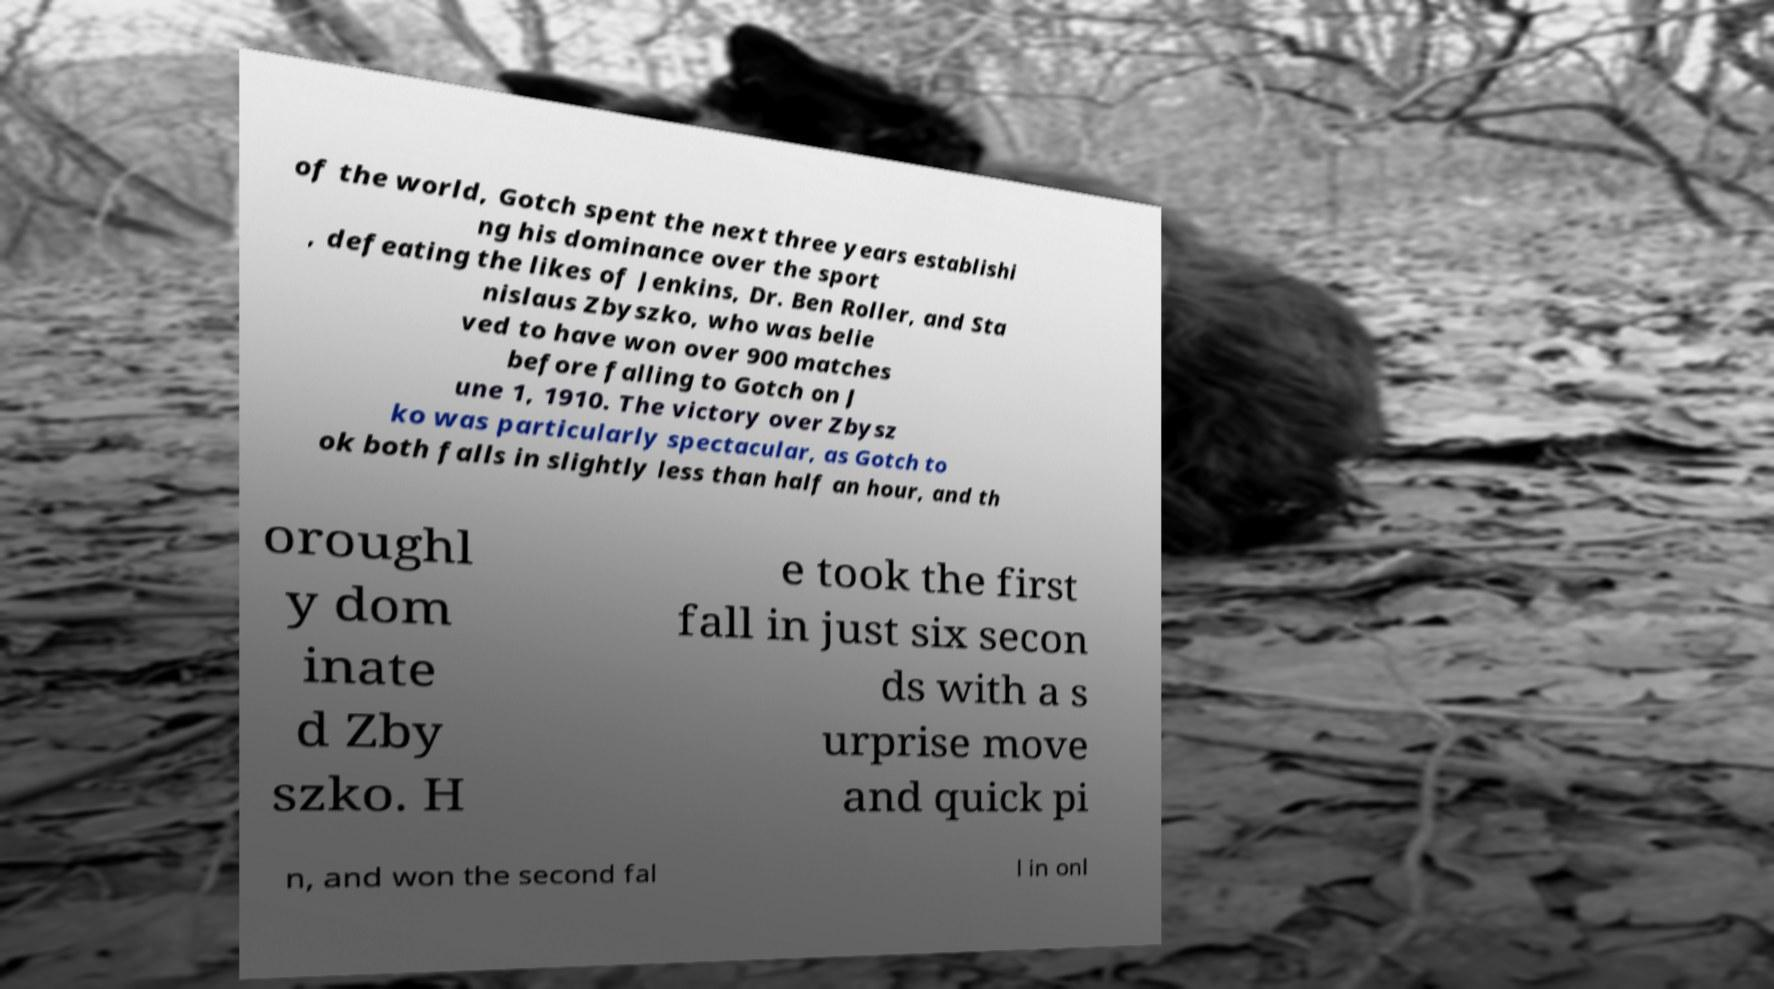I need the written content from this picture converted into text. Can you do that? of the world, Gotch spent the next three years establishi ng his dominance over the sport , defeating the likes of Jenkins, Dr. Ben Roller, and Sta nislaus Zbyszko, who was belie ved to have won over 900 matches before falling to Gotch on J une 1, 1910. The victory over Zbysz ko was particularly spectacular, as Gotch to ok both falls in slightly less than half an hour, and th oroughl y dom inate d Zby szko. H e took the first fall in just six secon ds with a s urprise move and quick pi n, and won the second fal l in onl 